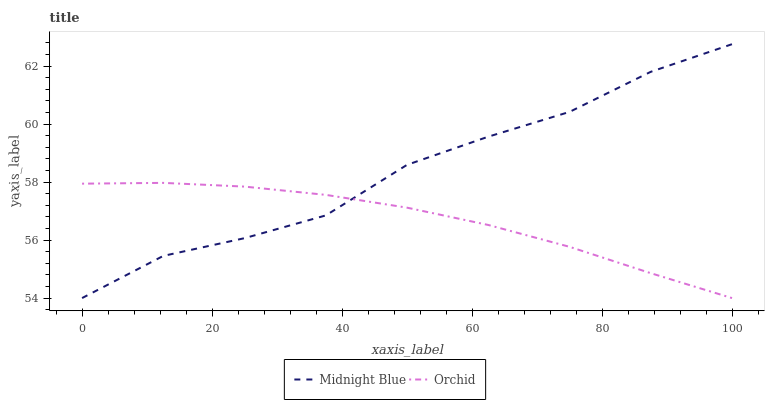Does Orchid have the minimum area under the curve?
Answer yes or no. Yes. Does Midnight Blue have the maximum area under the curve?
Answer yes or no. Yes. Does Orchid have the maximum area under the curve?
Answer yes or no. No. Is Orchid the smoothest?
Answer yes or no. Yes. Is Midnight Blue the roughest?
Answer yes or no. Yes. Is Orchid the roughest?
Answer yes or no. No. Does Midnight Blue have the lowest value?
Answer yes or no. Yes. Does Midnight Blue have the highest value?
Answer yes or no. Yes. Does Orchid have the highest value?
Answer yes or no. No. Does Orchid intersect Midnight Blue?
Answer yes or no. Yes. Is Orchid less than Midnight Blue?
Answer yes or no. No. Is Orchid greater than Midnight Blue?
Answer yes or no. No. 